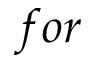<formula> <loc_0><loc_0><loc_500><loc_500>f o r</formula> 